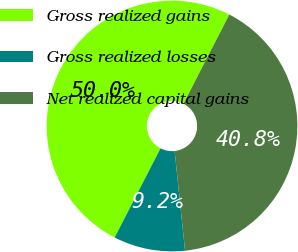Convert chart to OTSL. <chart><loc_0><loc_0><loc_500><loc_500><pie_chart><fcel>Gross realized gains<fcel>Gross realized losses<fcel>Net realized capital gains<nl><fcel>50.0%<fcel>9.22%<fcel>40.78%<nl></chart> 